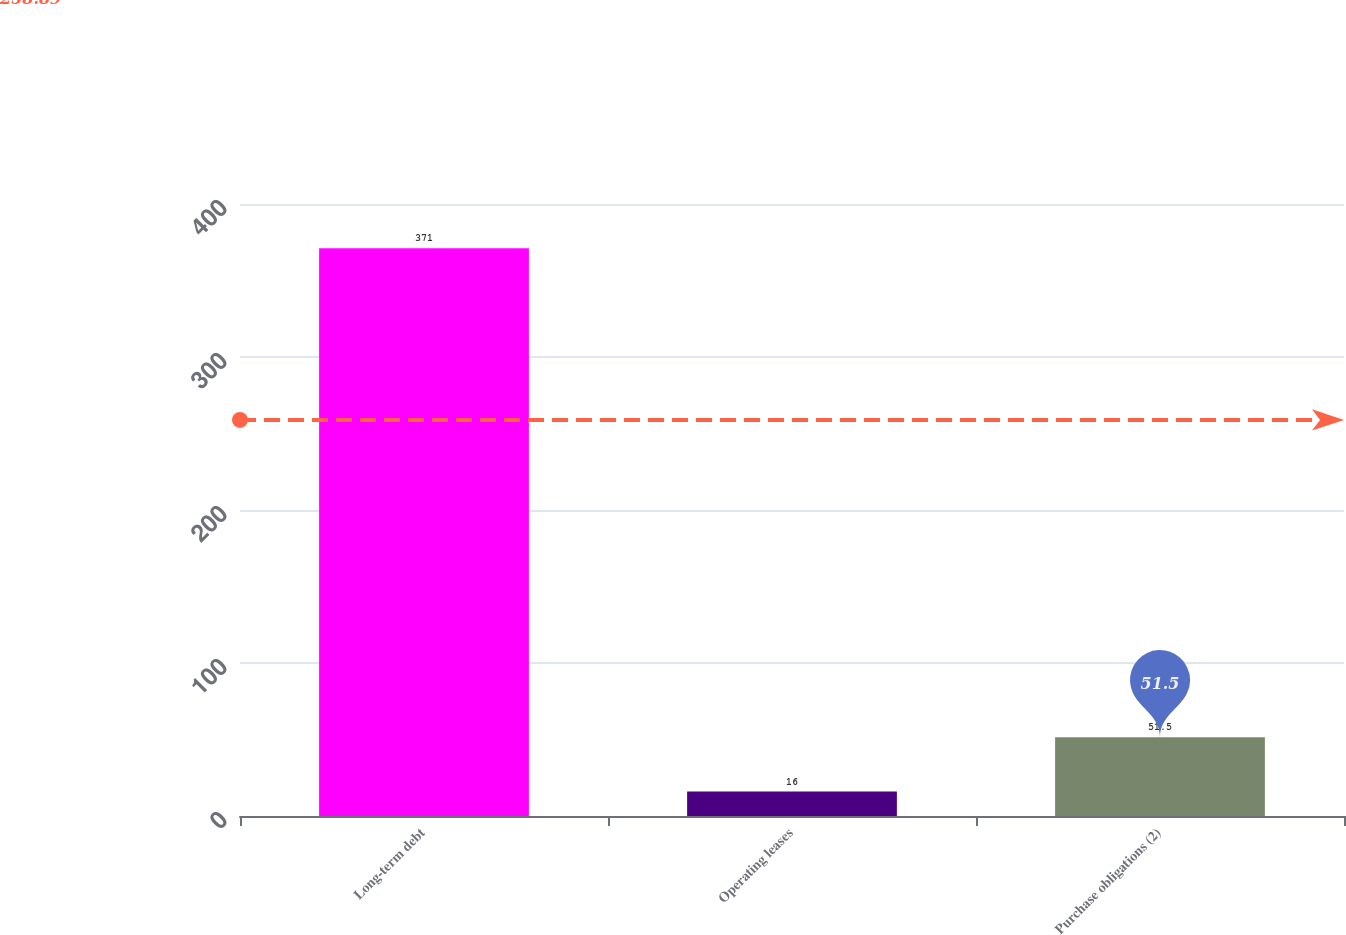<chart> <loc_0><loc_0><loc_500><loc_500><bar_chart><fcel>Long-term debt<fcel>Operating leases<fcel>Purchase obligations (2)<nl><fcel>371<fcel>16<fcel>51.5<nl></chart> 